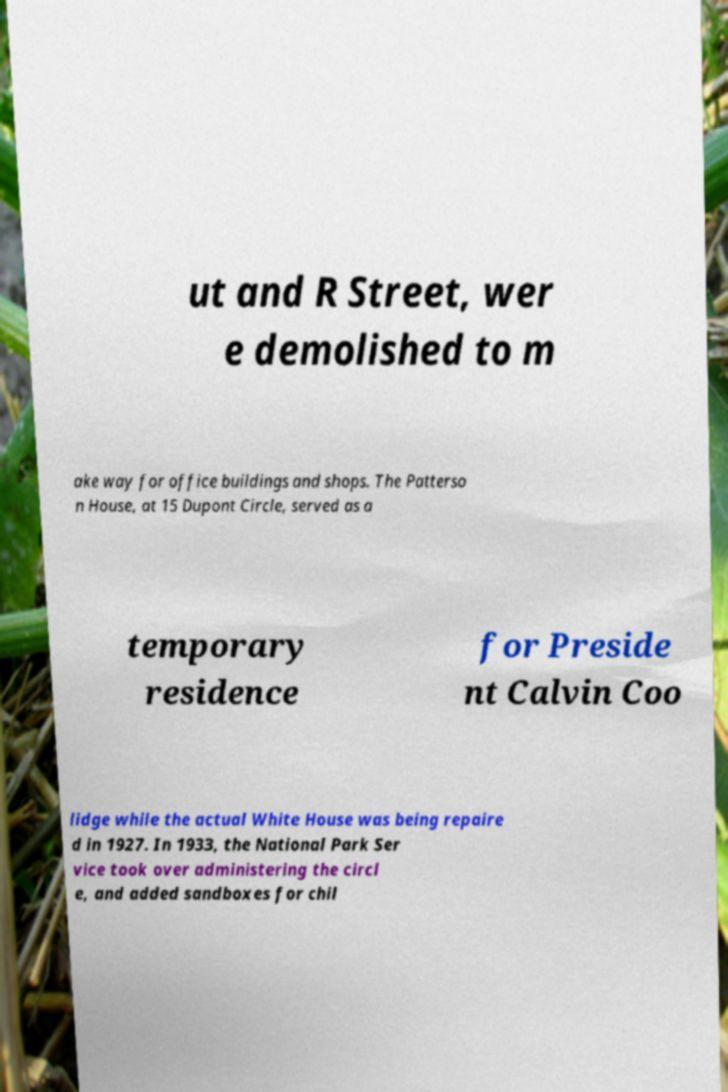Can you read and provide the text displayed in the image?This photo seems to have some interesting text. Can you extract and type it out for me? ut and R Street, wer e demolished to m ake way for office buildings and shops. The Patterso n House, at 15 Dupont Circle, served as a temporary residence for Preside nt Calvin Coo lidge while the actual White House was being repaire d in 1927. In 1933, the National Park Ser vice took over administering the circl e, and added sandboxes for chil 